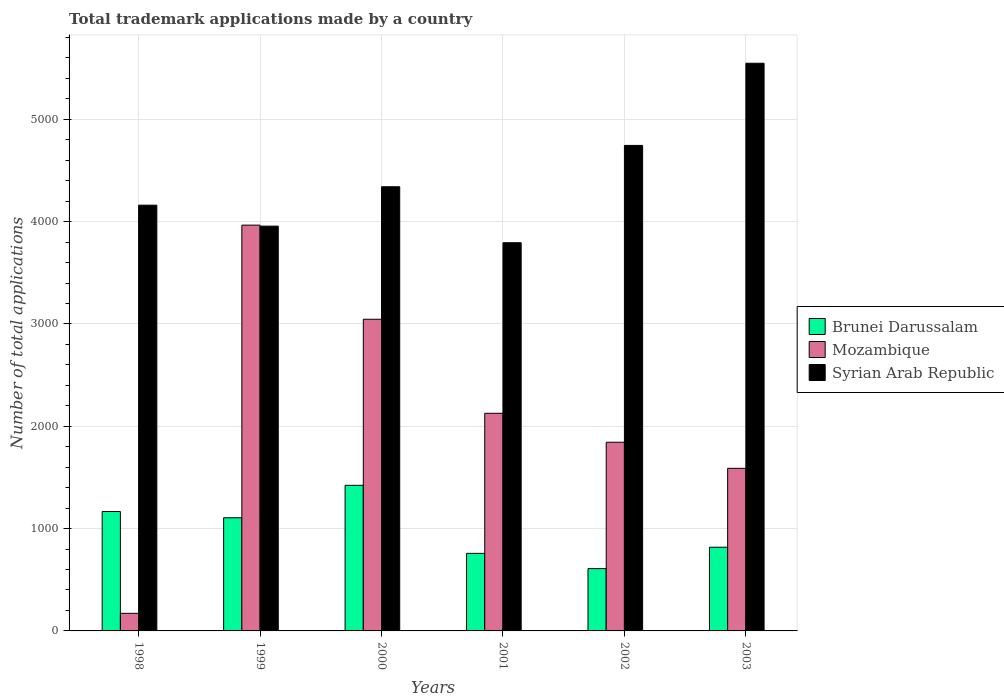Are the number of bars per tick equal to the number of legend labels?
Provide a short and direct response. Yes. How many bars are there on the 6th tick from the right?
Your answer should be very brief. 3. What is the number of applications made by in Brunei Darussalam in 2003?
Your response must be concise. 818. Across all years, what is the maximum number of applications made by in Mozambique?
Provide a short and direct response. 3966. Across all years, what is the minimum number of applications made by in Brunei Darussalam?
Give a very brief answer. 609. In which year was the number of applications made by in Mozambique maximum?
Provide a succinct answer. 1999. What is the total number of applications made by in Brunei Darussalam in the graph?
Provide a short and direct response. 5881. What is the difference between the number of applications made by in Syrian Arab Republic in 1999 and that in 2002?
Your answer should be very brief. -789. What is the difference between the number of applications made by in Brunei Darussalam in 2002 and the number of applications made by in Mozambique in 1999?
Your answer should be compact. -3357. What is the average number of applications made by in Mozambique per year?
Offer a very short reply. 2124. In the year 2000, what is the difference between the number of applications made by in Syrian Arab Republic and number of applications made by in Brunei Darussalam?
Ensure brevity in your answer.  2918. In how many years, is the number of applications made by in Mozambique greater than 3000?
Keep it short and to the point. 2. What is the ratio of the number of applications made by in Mozambique in 1999 to that in 2001?
Offer a terse response. 1.86. Is the number of applications made by in Mozambique in 1999 less than that in 2001?
Make the answer very short. No. Is the difference between the number of applications made by in Syrian Arab Republic in 2000 and 2003 greater than the difference between the number of applications made by in Brunei Darussalam in 2000 and 2003?
Make the answer very short. No. What is the difference between the highest and the second highest number of applications made by in Brunei Darussalam?
Ensure brevity in your answer.  256. What is the difference between the highest and the lowest number of applications made by in Syrian Arab Republic?
Give a very brief answer. 1754. In how many years, is the number of applications made by in Syrian Arab Republic greater than the average number of applications made by in Syrian Arab Republic taken over all years?
Give a very brief answer. 2. Is the sum of the number of applications made by in Brunei Darussalam in 2001 and 2002 greater than the maximum number of applications made by in Mozambique across all years?
Make the answer very short. No. What does the 2nd bar from the left in 2003 represents?
Give a very brief answer. Mozambique. What does the 1st bar from the right in 2002 represents?
Your answer should be compact. Syrian Arab Republic. Is it the case that in every year, the sum of the number of applications made by in Syrian Arab Republic and number of applications made by in Brunei Darussalam is greater than the number of applications made by in Mozambique?
Your answer should be compact. Yes. Does the graph contain grids?
Ensure brevity in your answer.  Yes. Where does the legend appear in the graph?
Offer a very short reply. Center right. How are the legend labels stacked?
Make the answer very short. Vertical. What is the title of the graph?
Your answer should be very brief. Total trademark applications made by a country. Does "San Marino" appear as one of the legend labels in the graph?
Offer a very short reply. No. What is the label or title of the X-axis?
Make the answer very short. Years. What is the label or title of the Y-axis?
Provide a short and direct response. Number of total applications. What is the Number of total applications of Brunei Darussalam in 1998?
Provide a short and direct response. 1167. What is the Number of total applications of Mozambique in 1998?
Your answer should be compact. 172. What is the Number of total applications in Syrian Arab Republic in 1998?
Make the answer very short. 4161. What is the Number of total applications in Brunei Darussalam in 1999?
Your answer should be compact. 1106. What is the Number of total applications in Mozambique in 1999?
Provide a succinct answer. 3966. What is the Number of total applications of Syrian Arab Republic in 1999?
Offer a very short reply. 3956. What is the Number of total applications in Brunei Darussalam in 2000?
Provide a succinct answer. 1423. What is the Number of total applications of Mozambique in 2000?
Your response must be concise. 3046. What is the Number of total applications in Syrian Arab Republic in 2000?
Make the answer very short. 4341. What is the Number of total applications of Brunei Darussalam in 2001?
Provide a succinct answer. 758. What is the Number of total applications of Mozambique in 2001?
Your response must be concise. 2127. What is the Number of total applications of Syrian Arab Republic in 2001?
Provide a short and direct response. 3794. What is the Number of total applications in Brunei Darussalam in 2002?
Ensure brevity in your answer.  609. What is the Number of total applications in Mozambique in 2002?
Your answer should be very brief. 1844. What is the Number of total applications in Syrian Arab Republic in 2002?
Offer a very short reply. 4745. What is the Number of total applications in Brunei Darussalam in 2003?
Make the answer very short. 818. What is the Number of total applications of Mozambique in 2003?
Make the answer very short. 1589. What is the Number of total applications in Syrian Arab Republic in 2003?
Offer a very short reply. 5548. Across all years, what is the maximum Number of total applications in Brunei Darussalam?
Make the answer very short. 1423. Across all years, what is the maximum Number of total applications of Mozambique?
Provide a short and direct response. 3966. Across all years, what is the maximum Number of total applications of Syrian Arab Republic?
Keep it short and to the point. 5548. Across all years, what is the minimum Number of total applications of Brunei Darussalam?
Your answer should be very brief. 609. Across all years, what is the minimum Number of total applications in Mozambique?
Your answer should be compact. 172. Across all years, what is the minimum Number of total applications of Syrian Arab Republic?
Make the answer very short. 3794. What is the total Number of total applications in Brunei Darussalam in the graph?
Provide a succinct answer. 5881. What is the total Number of total applications of Mozambique in the graph?
Ensure brevity in your answer.  1.27e+04. What is the total Number of total applications in Syrian Arab Republic in the graph?
Keep it short and to the point. 2.65e+04. What is the difference between the Number of total applications of Brunei Darussalam in 1998 and that in 1999?
Ensure brevity in your answer.  61. What is the difference between the Number of total applications of Mozambique in 1998 and that in 1999?
Keep it short and to the point. -3794. What is the difference between the Number of total applications of Syrian Arab Republic in 1998 and that in 1999?
Ensure brevity in your answer.  205. What is the difference between the Number of total applications of Brunei Darussalam in 1998 and that in 2000?
Offer a very short reply. -256. What is the difference between the Number of total applications of Mozambique in 1998 and that in 2000?
Offer a terse response. -2874. What is the difference between the Number of total applications in Syrian Arab Republic in 1998 and that in 2000?
Ensure brevity in your answer.  -180. What is the difference between the Number of total applications in Brunei Darussalam in 1998 and that in 2001?
Your response must be concise. 409. What is the difference between the Number of total applications in Mozambique in 1998 and that in 2001?
Make the answer very short. -1955. What is the difference between the Number of total applications of Syrian Arab Republic in 1998 and that in 2001?
Ensure brevity in your answer.  367. What is the difference between the Number of total applications in Brunei Darussalam in 1998 and that in 2002?
Offer a terse response. 558. What is the difference between the Number of total applications in Mozambique in 1998 and that in 2002?
Your answer should be very brief. -1672. What is the difference between the Number of total applications in Syrian Arab Republic in 1998 and that in 2002?
Offer a very short reply. -584. What is the difference between the Number of total applications of Brunei Darussalam in 1998 and that in 2003?
Make the answer very short. 349. What is the difference between the Number of total applications of Mozambique in 1998 and that in 2003?
Your answer should be compact. -1417. What is the difference between the Number of total applications of Syrian Arab Republic in 1998 and that in 2003?
Give a very brief answer. -1387. What is the difference between the Number of total applications of Brunei Darussalam in 1999 and that in 2000?
Your answer should be compact. -317. What is the difference between the Number of total applications of Mozambique in 1999 and that in 2000?
Your response must be concise. 920. What is the difference between the Number of total applications in Syrian Arab Republic in 1999 and that in 2000?
Provide a succinct answer. -385. What is the difference between the Number of total applications of Brunei Darussalam in 1999 and that in 2001?
Offer a very short reply. 348. What is the difference between the Number of total applications of Mozambique in 1999 and that in 2001?
Provide a succinct answer. 1839. What is the difference between the Number of total applications in Syrian Arab Republic in 1999 and that in 2001?
Your answer should be very brief. 162. What is the difference between the Number of total applications in Brunei Darussalam in 1999 and that in 2002?
Offer a very short reply. 497. What is the difference between the Number of total applications in Mozambique in 1999 and that in 2002?
Offer a very short reply. 2122. What is the difference between the Number of total applications of Syrian Arab Republic in 1999 and that in 2002?
Keep it short and to the point. -789. What is the difference between the Number of total applications in Brunei Darussalam in 1999 and that in 2003?
Ensure brevity in your answer.  288. What is the difference between the Number of total applications of Mozambique in 1999 and that in 2003?
Offer a terse response. 2377. What is the difference between the Number of total applications of Syrian Arab Republic in 1999 and that in 2003?
Offer a very short reply. -1592. What is the difference between the Number of total applications of Brunei Darussalam in 2000 and that in 2001?
Ensure brevity in your answer.  665. What is the difference between the Number of total applications in Mozambique in 2000 and that in 2001?
Give a very brief answer. 919. What is the difference between the Number of total applications of Syrian Arab Republic in 2000 and that in 2001?
Ensure brevity in your answer.  547. What is the difference between the Number of total applications of Brunei Darussalam in 2000 and that in 2002?
Keep it short and to the point. 814. What is the difference between the Number of total applications of Mozambique in 2000 and that in 2002?
Your response must be concise. 1202. What is the difference between the Number of total applications of Syrian Arab Republic in 2000 and that in 2002?
Your answer should be very brief. -404. What is the difference between the Number of total applications in Brunei Darussalam in 2000 and that in 2003?
Your answer should be compact. 605. What is the difference between the Number of total applications in Mozambique in 2000 and that in 2003?
Give a very brief answer. 1457. What is the difference between the Number of total applications of Syrian Arab Republic in 2000 and that in 2003?
Your answer should be very brief. -1207. What is the difference between the Number of total applications of Brunei Darussalam in 2001 and that in 2002?
Your response must be concise. 149. What is the difference between the Number of total applications of Mozambique in 2001 and that in 2002?
Provide a succinct answer. 283. What is the difference between the Number of total applications in Syrian Arab Republic in 2001 and that in 2002?
Your answer should be compact. -951. What is the difference between the Number of total applications of Brunei Darussalam in 2001 and that in 2003?
Make the answer very short. -60. What is the difference between the Number of total applications of Mozambique in 2001 and that in 2003?
Your answer should be very brief. 538. What is the difference between the Number of total applications of Syrian Arab Republic in 2001 and that in 2003?
Provide a succinct answer. -1754. What is the difference between the Number of total applications in Brunei Darussalam in 2002 and that in 2003?
Ensure brevity in your answer.  -209. What is the difference between the Number of total applications in Mozambique in 2002 and that in 2003?
Ensure brevity in your answer.  255. What is the difference between the Number of total applications in Syrian Arab Republic in 2002 and that in 2003?
Keep it short and to the point. -803. What is the difference between the Number of total applications of Brunei Darussalam in 1998 and the Number of total applications of Mozambique in 1999?
Your answer should be very brief. -2799. What is the difference between the Number of total applications in Brunei Darussalam in 1998 and the Number of total applications in Syrian Arab Republic in 1999?
Offer a very short reply. -2789. What is the difference between the Number of total applications in Mozambique in 1998 and the Number of total applications in Syrian Arab Republic in 1999?
Keep it short and to the point. -3784. What is the difference between the Number of total applications of Brunei Darussalam in 1998 and the Number of total applications of Mozambique in 2000?
Provide a succinct answer. -1879. What is the difference between the Number of total applications in Brunei Darussalam in 1998 and the Number of total applications in Syrian Arab Republic in 2000?
Give a very brief answer. -3174. What is the difference between the Number of total applications in Mozambique in 1998 and the Number of total applications in Syrian Arab Republic in 2000?
Give a very brief answer. -4169. What is the difference between the Number of total applications in Brunei Darussalam in 1998 and the Number of total applications in Mozambique in 2001?
Offer a terse response. -960. What is the difference between the Number of total applications in Brunei Darussalam in 1998 and the Number of total applications in Syrian Arab Republic in 2001?
Give a very brief answer. -2627. What is the difference between the Number of total applications of Mozambique in 1998 and the Number of total applications of Syrian Arab Republic in 2001?
Give a very brief answer. -3622. What is the difference between the Number of total applications of Brunei Darussalam in 1998 and the Number of total applications of Mozambique in 2002?
Provide a short and direct response. -677. What is the difference between the Number of total applications in Brunei Darussalam in 1998 and the Number of total applications in Syrian Arab Republic in 2002?
Keep it short and to the point. -3578. What is the difference between the Number of total applications of Mozambique in 1998 and the Number of total applications of Syrian Arab Republic in 2002?
Your answer should be very brief. -4573. What is the difference between the Number of total applications in Brunei Darussalam in 1998 and the Number of total applications in Mozambique in 2003?
Provide a succinct answer. -422. What is the difference between the Number of total applications of Brunei Darussalam in 1998 and the Number of total applications of Syrian Arab Republic in 2003?
Your answer should be compact. -4381. What is the difference between the Number of total applications in Mozambique in 1998 and the Number of total applications in Syrian Arab Republic in 2003?
Provide a succinct answer. -5376. What is the difference between the Number of total applications in Brunei Darussalam in 1999 and the Number of total applications in Mozambique in 2000?
Make the answer very short. -1940. What is the difference between the Number of total applications in Brunei Darussalam in 1999 and the Number of total applications in Syrian Arab Republic in 2000?
Give a very brief answer. -3235. What is the difference between the Number of total applications of Mozambique in 1999 and the Number of total applications of Syrian Arab Republic in 2000?
Your answer should be very brief. -375. What is the difference between the Number of total applications of Brunei Darussalam in 1999 and the Number of total applications of Mozambique in 2001?
Make the answer very short. -1021. What is the difference between the Number of total applications in Brunei Darussalam in 1999 and the Number of total applications in Syrian Arab Republic in 2001?
Your answer should be very brief. -2688. What is the difference between the Number of total applications in Mozambique in 1999 and the Number of total applications in Syrian Arab Republic in 2001?
Provide a succinct answer. 172. What is the difference between the Number of total applications in Brunei Darussalam in 1999 and the Number of total applications in Mozambique in 2002?
Keep it short and to the point. -738. What is the difference between the Number of total applications in Brunei Darussalam in 1999 and the Number of total applications in Syrian Arab Republic in 2002?
Your response must be concise. -3639. What is the difference between the Number of total applications in Mozambique in 1999 and the Number of total applications in Syrian Arab Republic in 2002?
Make the answer very short. -779. What is the difference between the Number of total applications in Brunei Darussalam in 1999 and the Number of total applications in Mozambique in 2003?
Keep it short and to the point. -483. What is the difference between the Number of total applications of Brunei Darussalam in 1999 and the Number of total applications of Syrian Arab Republic in 2003?
Your response must be concise. -4442. What is the difference between the Number of total applications of Mozambique in 1999 and the Number of total applications of Syrian Arab Republic in 2003?
Provide a succinct answer. -1582. What is the difference between the Number of total applications of Brunei Darussalam in 2000 and the Number of total applications of Mozambique in 2001?
Your answer should be compact. -704. What is the difference between the Number of total applications in Brunei Darussalam in 2000 and the Number of total applications in Syrian Arab Republic in 2001?
Ensure brevity in your answer.  -2371. What is the difference between the Number of total applications of Mozambique in 2000 and the Number of total applications of Syrian Arab Republic in 2001?
Keep it short and to the point. -748. What is the difference between the Number of total applications of Brunei Darussalam in 2000 and the Number of total applications of Mozambique in 2002?
Keep it short and to the point. -421. What is the difference between the Number of total applications of Brunei Darussalam in 2000 and the Number of total applications of Syrian Arab Republic in 2002?
Your answer should be compact. -3322. What is the difference between the Number of total applications in Mozambique in 2000 and the Number of total applications in Syrian Arab Republic in 2002?
Give a very brief answer. -1699. What is the difference between the Number of total applications of Brunei Darussalam in 2000 and the Number of total applications of Mozambique in 2003?
Provide a short and direct response. -166. What is the difference between the Number of total applications in Brunei Darussalam in 2000 and the Number of total applications in Syrian Arab Republic in 2003?
Give a very brief answer. -4125. What is the difference between the Number of total applications of Mozambique in 2000 and the Number of total applications of Syrian Arab Republic in 2003?
Your response must be concise. -2502. What is the difference between the Number of total applications of Brunei Darussalam in 2001 and the Number of total applications of Mozambique in 2002?
Make the answer very short. -1086. What is the difference between the Number of total applications in Brunei Darussalam in 2001 and the Number of total applications in Syrian Arab Republic in 2002?
Give a very brief answer. -3987. What is the difference between the Number of total applications of Mozambique in 2001 and the Number of total applications of Syrian Arab Republic in 2002?
Ensure brevity in your answer.  -2618. What is the difference between the Number of total applications in Brunei Darussalam in 2001 and the Number of total applications in Mozambique in 2003?
Ensure brevity in your answer.  -831. What is the difference between the Number of total applications in Brunei Darussalam in 2001 and the Number of total applications in Syrian Arab Republic in 2003?
Your response must be concise. -4790. What is the difference between the Number of total applications in Mozambique in 2001 and the Number of total applications in Syrian Arab Republic in 2003?
Your answer should be very brief. -3421. What is the difference between the Number of total applications of Brunei Darussalam in 2002 and the Number of total applications of Mozambique in 2003?
Your response must be concise. -980. What is the difference between the Number of total applications in Brunei Darussalam in 2002 and the Number of total applications in Syrian Arab Republic in 2003?
Your answer should be compact. -4939. What is the difference between the Number of total applications of Mozambique in 2002 and the Number of total applications of Syrian Arab Republic in 2003?
Your response must be concise. -3704. What is the average Number of total applications of Brunei Darussalam per year?
Ensure brevity in your answer.  980.17. What is the average Number of total applications of Mozambique per year?
Offer a terse response. 2124. What is the average Number of total applications in Syrian Arab Republic per year?
Ensure brevity in your answer.  4424.17. In the year 1998, what is the difference between the Number of total applications in Brunei Darussalam and Number of total applications in Mozambique?
Provide a succinct answer. 995. In the year 1998, what is the difference between the Number of total applications in Brunei Darussalam and Number of total applications in Syrian Arab Republic?
Your response must be concise. -2994. In the year 1998, what is the difference between the Number of total applications of Mozambique and Number of total applications of Syrian Arab Republic?
Keep it short and to the point. -3989. In the year 1999, what is the difference between the Number of total applications in Brunei Darussalam and Number of total applications in Mozambique?
Your answer should be very brief. -2860. In the year 1999, what is the difference between the Number of total applications in Brunei Darussalam and Number of total applications in Syrian Arab Republic?
Your response must be concise. -2850. In the year 2000, what is the difference between the Number of total applications of Brunei Darussalam and Number of total applications of Mozambique?
Offer a terse response. -1623. In the year 2000, what is the difference between the Number of total applications of Brunei Darussalam and Number of total applications of Syrian Arab Republic?
Provide a succinct answer. -2918. In the year 2000, what is the difference between the Number of total applications of Mozambique and Number of total applications of Syrian Arab Republic?
Your answer should be very brief. -1295. In the year 2001, what is the difference between the Number of total applications in Brunei Darussalam and Number of total applications in Mozambique?
Your answer should be compact. -1369. In the year 2001, what is the difference between the Number of total applications in Brunei Darussalam and Number of total applications in Syrian Arab Republic?
Offer a terse response. -3036. In the year 2001, what is the difference between the Number of total applications in Mozambique and Number of total applications in Syrian Arab Republic?
Keep it short and to the point. -1667. In the year 2002, what is the difference between the Number of total applications in Brunei Darussalam and Number of total applications in Mozambique?
Keep it short and to the point. -1235. In the year 2002, what is the difference between the Number of total applications in Brunei Darussalam and Number of total applications in Syrian Arab Republic?
Provide a succinct answer. -4136. In the year 2002, what is the difference between the Number of total applications of Mozambique and Number of total applications of Syrian Arab Republic?
Keep it short and to the point. -2901. In the year 2003, what is the difference between the Number of total applications in Brunei Darussalam and Number of total applications in Mozambique?
Provide a short and direct response. -771. In the year 2003, what is the difference between the Number of total applications of Brunei Darussalam and Number of total applications of Syrian Arab Republic?
Offer a very short reply. -4730. In the year 2003, what is the difference between the Number of total applications of Mozambique and Number of total applications of Syrian Arab Republic?
Offer a very short reply. -3959. What is the ratio of the Number of total applications of Brunei Darussalam in 1998 to that in 1999?
Your answer should be very brief. 1.06. What is the ratio of the Number of total applications in Mozambique in 1998 to that in 1999?
Provide a short and direct response. 0.04. What is the ratio of the Number of total applications in Syrian Arab Republic in 1998 to that in 1999?
Provide a short and direct response. 1.05. What is the ratio of the Number of total applications of Brunei Darussalam in 1998 to that in 2000?
Your answer should be compact. 0.82. What is the ratio of the Number of total applications of Mozambique in 1998 to that in 2000?
Make the answer very short. 0.06. What is the ratio of the Number of total applications of Syrian Arab Republic in 1998 to that in 2000?
Ensure brevity in your answer.  0.96. What is the ratio of the Number of total applications of Brunei Darussalam in 1998 to that in 2001?
Ensure brevity in your answer.  1.54. What is the ratio of the Number of total applications of Mozambique in 1998 to that in 2001?
Provide a succinct answer. 0.08. What is the ratio of the Number of total applications of Syrian Arab Republic in 1998 to that in 2001?
Your answer should be compact. 1.1. What is the ratio of the Number of total applications in Brunei Darussalam in 1998 to that in 2002?
Your answer should be compact. 1.92. What is the ratio of the Number of total applications in Mozambique in 1998 to that in 2002?
Provide a succinct answer. 0.09. What is the ratio of the Number of total applications of Syrian Arab Republic in 1998 to that in 2002?
Provide a short and direct response. 0.88. What is the ratio of the Number of total applications of Brunei Darussalam in 1998 to that in 2003?
Your answer should be compact. 1.43. What is the ratio of the Number of total applications in Mozambique in 1998 to that in 2003?
Offer a terse response. 0.11. What is the ratio of the Number of total applications of Brunei Darussalam in 1999 to that in 2000?
Make the answer very short. 0.78. What is the ratio of the Number of total applications in Mozambique in 1999 to that in 2000?
Your answer should be very brief. 1.3. What is the ratio of the Number of total applications of Syrian Arab Republic in 1999 to that in 2000?
Ensure brevity in your answer.  0.91. What is the ratio of the Number of total applications in Brunei Darussalam in 1999 to that in 2001?
Give a very brief answer. 1.46. What is the ratio of the Number of total applications of Mozambique in 1999 to that in 2001?
Keep it short and to the point. 1.86. What is the ratio of the Number of total applications in Syrian Arab Republic in 1999 to that in 2001?
Ensure brevity in your answer.  1.04. What is the ratio of the Number of total applications of Brunei Darussalam in 1999 to that in 2002?
Provide a short and direct response. 1.82. What is the ratio of the Number of total applications in Mozambique in 1999 to that in 2002?
Offer a very short reply. 2.15. What is the ratio of the Number of total applications of Syrian Arab Republic in 1999 to that in 2002?
Give a very brief answer. 0.83. What is the ratio of the Number of total applications of Brunei Darussalam in 1999 to that in 2003?
Provide a succinct answer. 1.35. What is the ratio of the Number of total applications in Mozambique in 1999 to that in 2003?
Provide a short and direct response. 2.5. What is the ratio of the Number of total applications of Syrian Arab Republic in 1999 to that in 2003?
Keep it short and to the point. 0.71. What is the ratio of the Number of total applications of Brunei Darussalam in 2000 to that in 2001?
Offer a terse response. 1.88. What is the ratio of the Number of total applications of Mozambique in 2000 to that in 2001?
Offer a terse response. 1.43. What is the ratio of the Number of total applications of Syrian Arab Republic in 2000 to that in 2001?
Provide a succinct answer. 1.14. What is the ratio of the Number of total applications of Brunei Darussalam in 2000 to that in 2002?
Your response must be concise. 2.34. What is the ratio of the Number of total applications in Mozambique in 2000 to that in 2002?
Provide a short and direct response. 1.65. What is the ratio of the Number of total applications of Syrian Arab Republic in 2000 to that in 2002?
Offer a terse response. 0.91. What is the ratio of the Number of total applications of Brunei Darussalam in 2000 to that in 2003?
Make the answer very short. 1.74. What is the ratio of the Number of total applications of Mozambique in 2000 to that in 2003?
Ensure brevity in your answer.  1.92. What is the ratio of the Number of total applications in Syrian Arab Republic in 2000 to that in 2003?
Provide a short and direct response. 0.78. What is the ratio of the Number of total applications of Brunei Darussalam in 2001 to that in 2002?
Your answer should be compact. 1.24. What is the ratio of the Number of total applications of Mozambique in 2001 to that in 2002?
Your response must be concise. 1.15. What is the ratio of the Number of total applications in Syrian Arab Republic in 2001 to that in 2002?
Make the answer very short. 0.8. What is the ratio of the Number of total applications in Brunei Darussalam in 2001 to that in 2003?
Your response must be concise. 0.93. What is the ratio of the Number of total applications in Mozambique in 2001 to that in 2003?
Give a very brief answer. 1.34. What is the ratio of the Number of total applications in Syrian Arab Republic in 2001 to that in 2003?
Give a very brief answer. 0.68. What is the ratio of the Number of total applications of Brunei Darussalam in 2002 to that in 2003?
Ensure brevity in your answer.  0.74. What is the ratio of the Number of total applications of Mozambique in 2002 to that in 2003?
Your answer should be compact. 1.16. What is the ratio of the Number of total applications in Syrian Arab Republic in 2002 to that in 2003?
Give a very brief answer. 0.86. What is the difference between the highest and the second highest Number of total applications of Brunei Darussalam?
Your answer should be very brief. 256. What is the difference between the highest and the second highest Number of total applications in Mozambique?
Offer a very short reply. 920. What is the difference between the highest and the second highest Number of total applications in Syrian Arab Republic?
Give a very brief answer. 803. What is the difference between the highest and the lowest Number of total applications in Brunei Darussalam?
Make the answer very short. 814. What is the difference between the highest and the lowest Number of total applications of Mozambique?
Make the answer very short. 3794. What is the difference between the highest and the lowest Number of total applications of Syrian Arab Republic?
Provide a succinct answer. 1754. 